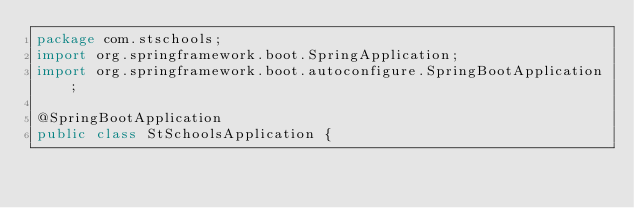<code> <loc_0><loc_0><loc_500><loc_500><_Java_>package com.stschools;
import org.springframework.boot.SpringApplication;
import org.springframework.boot.autoconfigure.SpringBootApplication;

@SpringBootApplication
public class StSchoolsApplication {</code> 